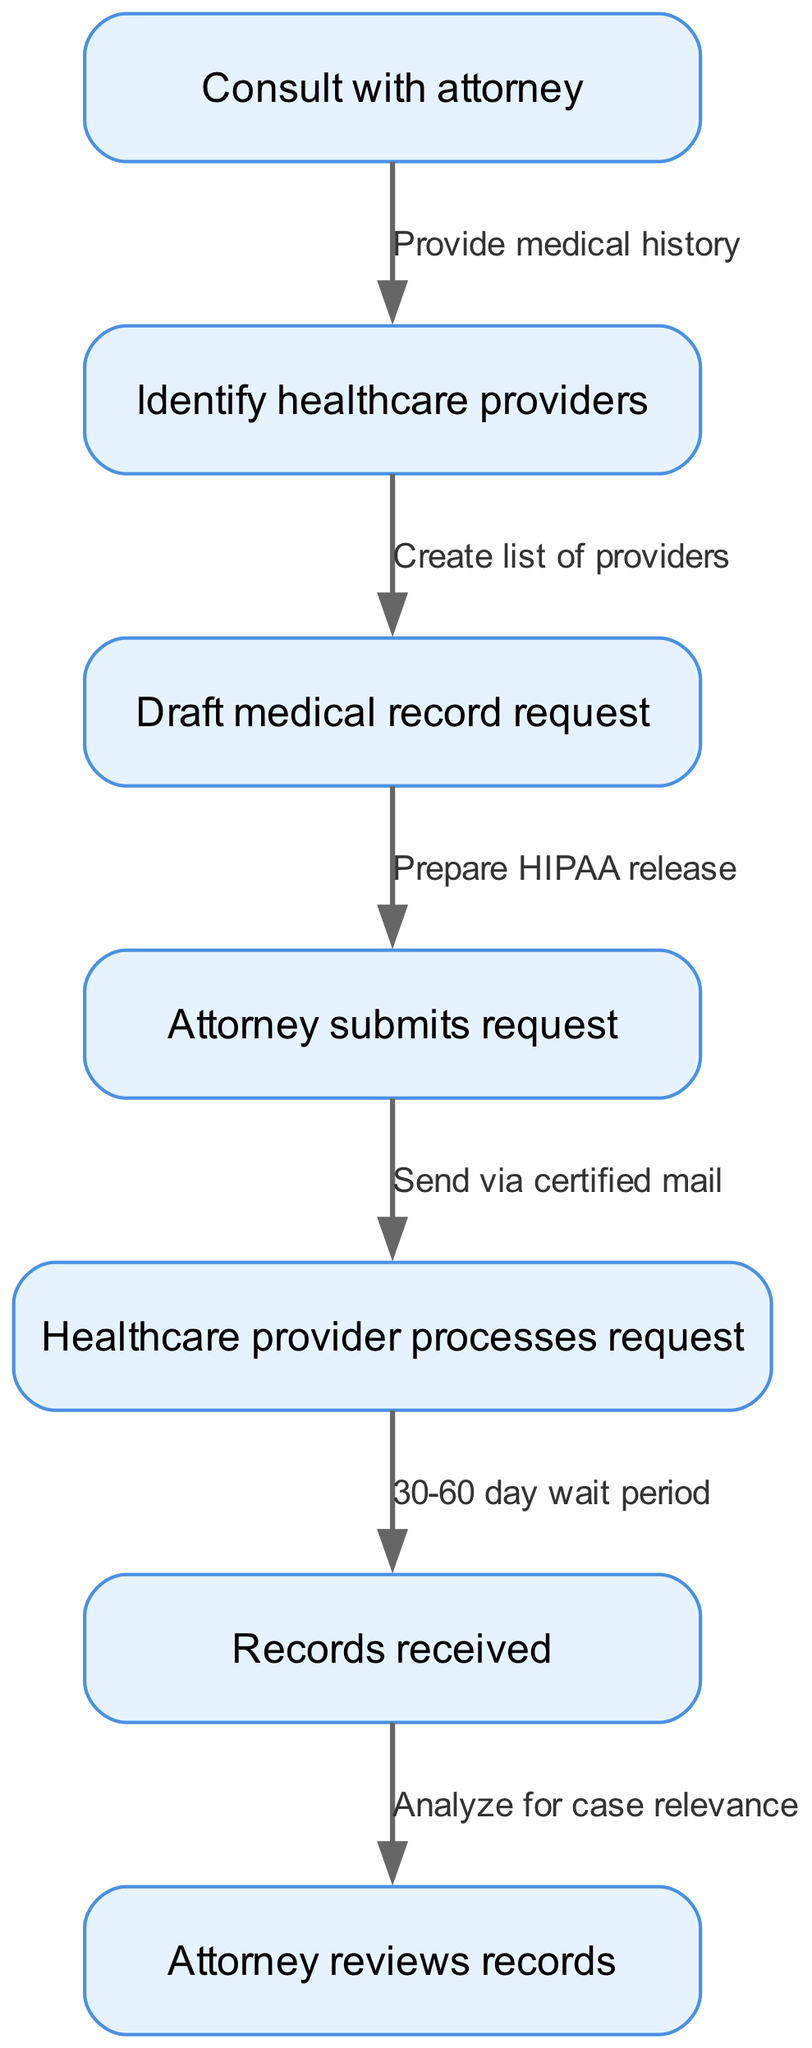What is the first step in the process? The first step in the process, as indicated by the top node, is "Consult with attorney."
Answer: Consult with attorney How many nodes are present in the diagram? By counting all the nodes listed, the diagram contains a total of 7 nodes.
Answer: 7 What is the relationship between "Attorney submits request" and "Healthcare provider processes request"? The flow from "Attorney submits request" to "Healthcare provider processes request" indicates that the attorney's action directly leads to the processing of the request by the healthcare provider.
Answer: Directly related What is the time frame mentioned for processing the medical record request? The diagram specifies a "30-60 day wait period," indicating the time frame within which the healthcare provider is expected to process the request.
Answer: 30-60 day wait period What action needs to be taken after receiving the medical records? After the records are received, the next action is for the attorney to review the records, making this a necessary step to progress further in the lawsuit.
Answer: Attorney reviews records What step follows "Draft medical record request"? Following the drafting of the medical record request, the next step is to have the attorney submit that request, establishing a sequence in the process.
Answer: Attorney submits request Which node comes before "Records received"? The node that leads into "Records received" is "Healthcare provider processes request," indicating that the processing of the request is essential before the records can be received.
Answer: Healthcare provider processes request What does the edge label between "Draft medical record request" and "Attorney submits request" signify? The edge label "Prepare HIPAA release" signifies that a HIPAA release needs to be prepared as part of drafting the medical record request before submission.
Answer: Prepare HIPAA release 